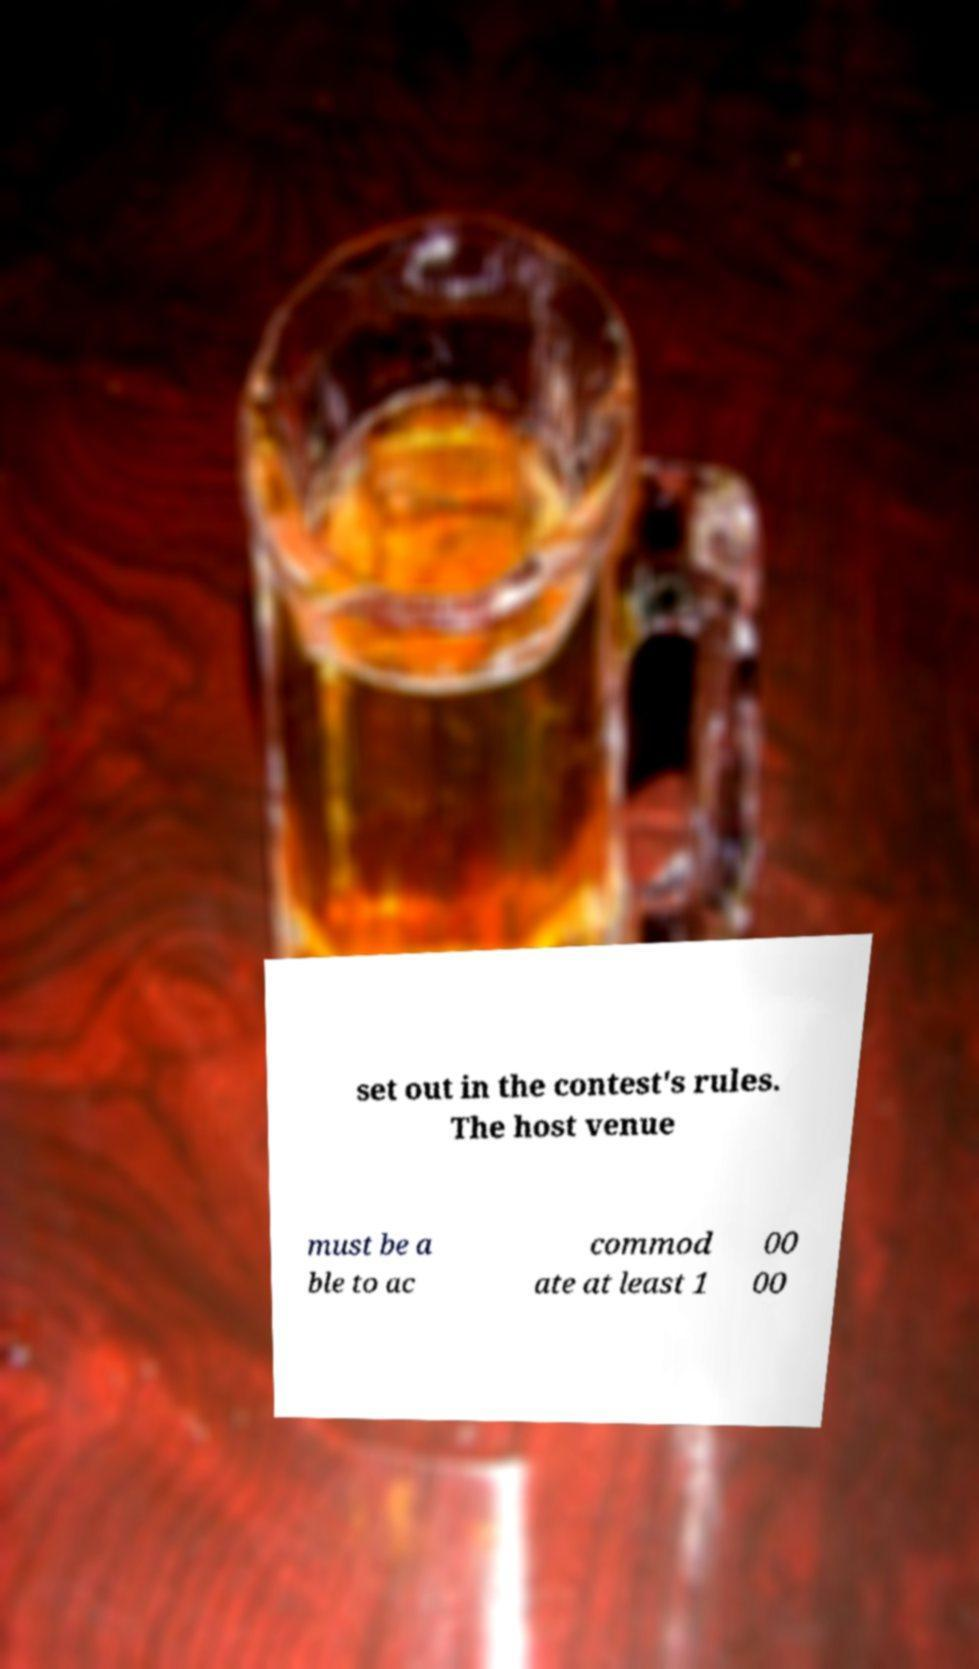I need the written content from this picture converted into text. Can you do that? set out in the contest's rules. The host venue must be a ble to ac commod ate at least 1 00 00 